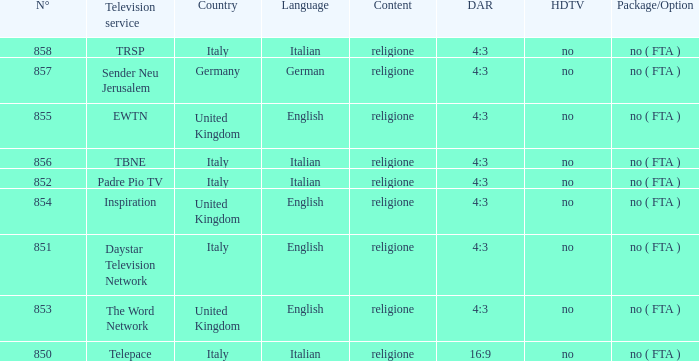What television service is in italy and is in english? Daystar Television Network. 